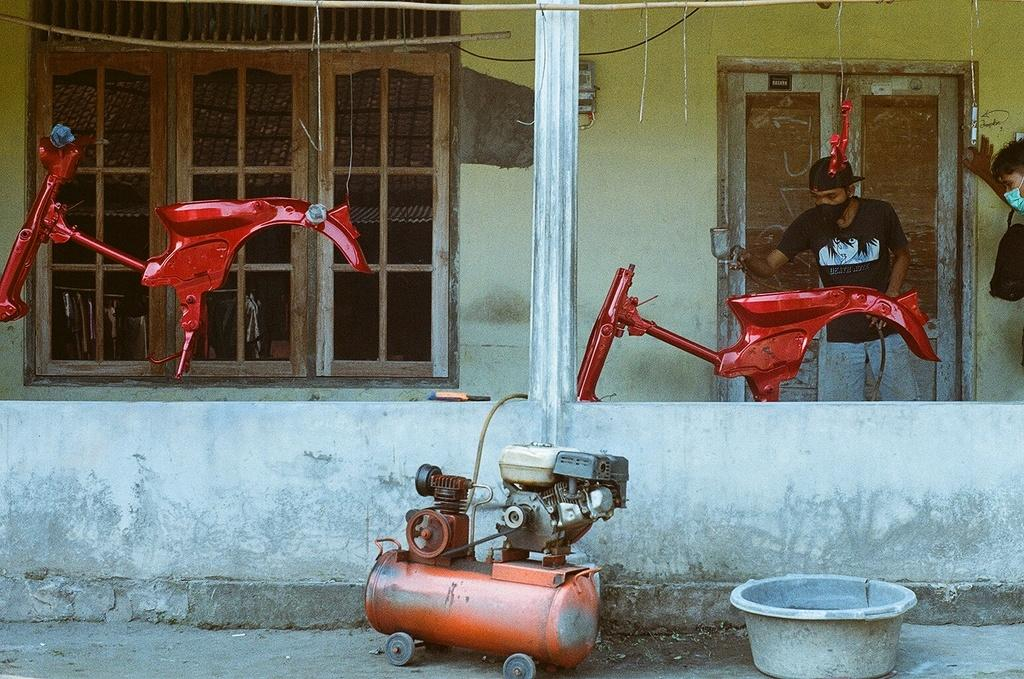What is the man in the image doing? The man is painting a bike in the image. What tool or equipment is the man using to paint the bike? There is a compressor in the image, which suggests that the man might be using it to paint the bike. What can be seen in the background of the image? There is a wall, a door, and windows in the background of the image. What is the mass of the building in the image? There is no building present in the image; it features a man painting a bike with a compressor in the background. 